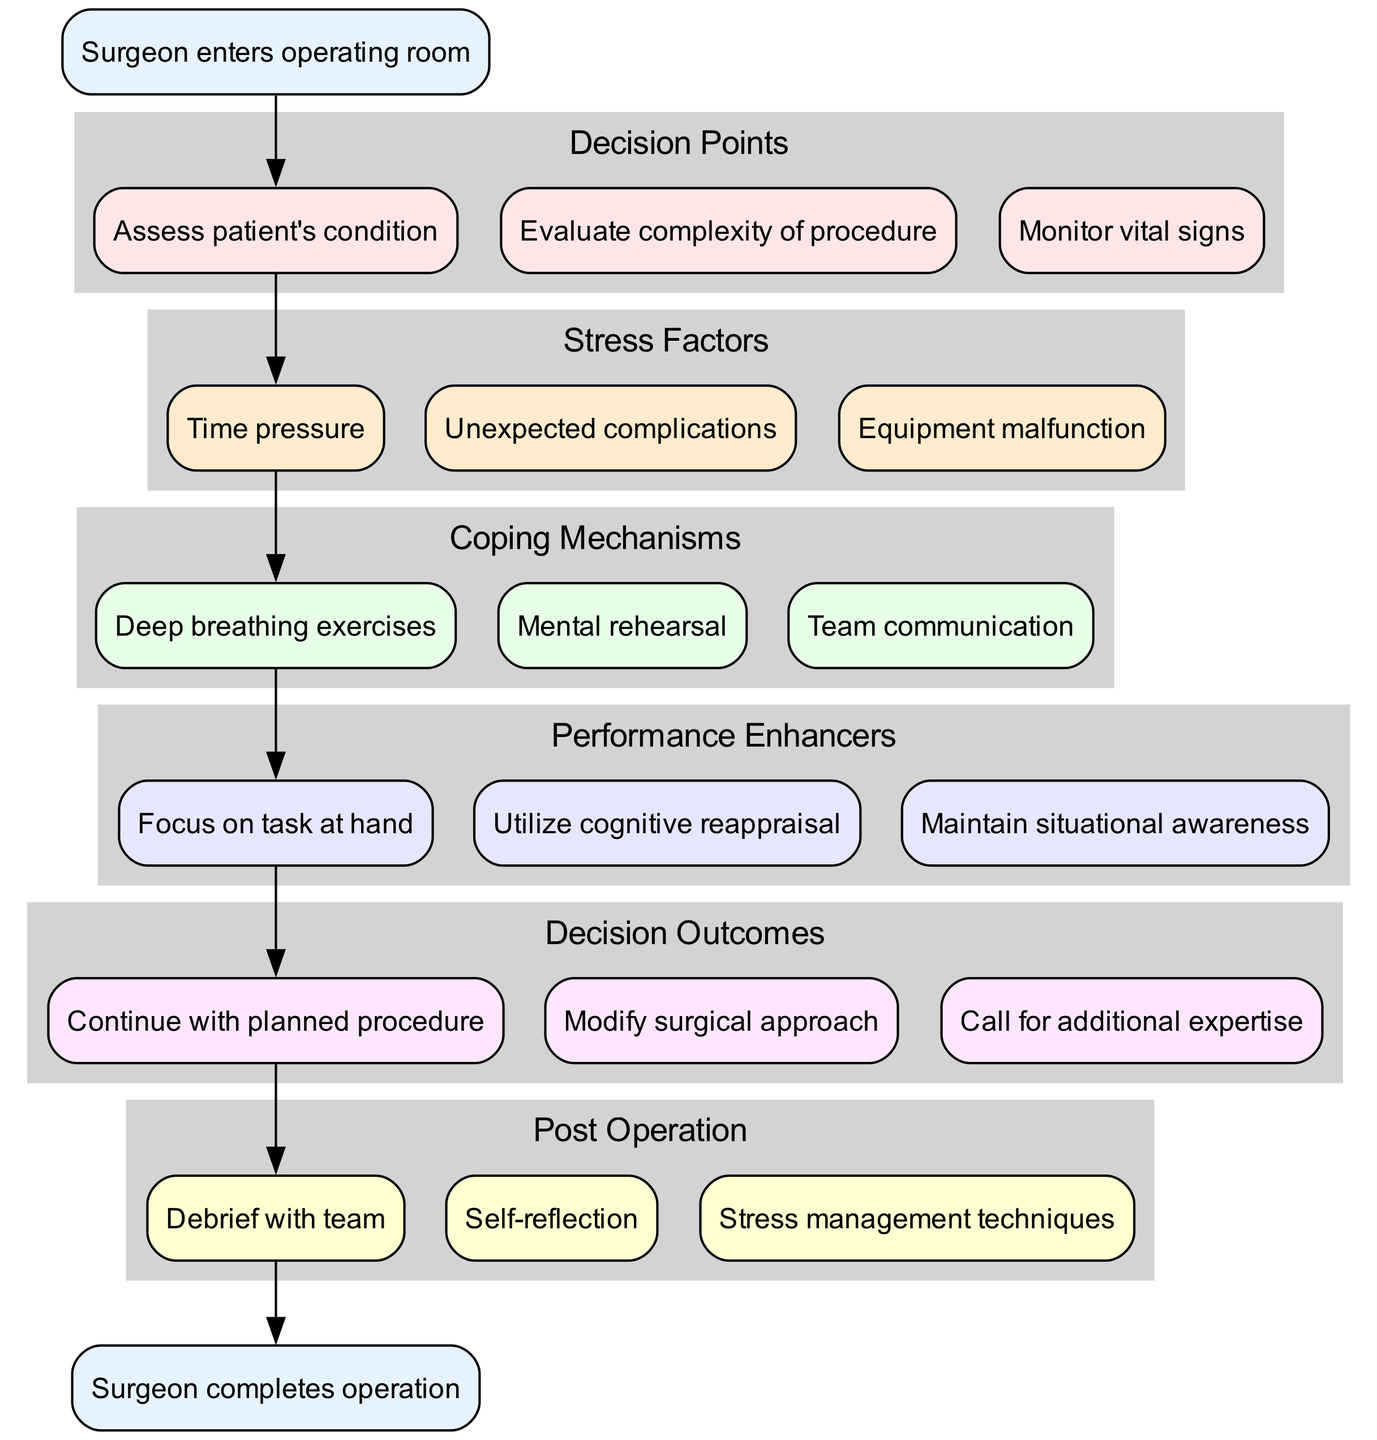What is the first action a surgeon takes upon entering the operating room? The first action as indicated in the diagram is "Surgeon enters operating room." This node is the starting point of the flow chart.
Answer: Surgeon enters operating room What are the stress factors outlined in the diagram? The stress factors are listed as nodes in the "Stress Factors" cluster. They include "Time pressure," "Unexpected complications," and "Equipment malfunction."
Answer: Time pressure, Unexpected complications, Equipment malfunction How many coping mechanisms are mentioned in the flow chart? The diagram includes three nodes under the "Coping Mechanisms" cluster, specifying the coping strategies available to surgeons.
Answer: 3 Which performance enhancer follows the mental rehearsal coping mechanism? Following the "Mental rehearsal" node in the coping mechanisms, the next node in the flow is "Focus on task at hand." This arrangement shows the sequence of applying coping strategies leading to enhanced performance.
Answer: Focus on task at hand If a surgeon faces unexpected complications, what is the expected outcome based on the diagram? Given the stress factor of "Unexpected complications," the flow would likely lead to a decision point. Consequently, this would affect the outcome, potentially to "Modify surgical approach," as this modification reacts to the complexity of the situation.
Answer: Modify surgical approach What does the end node signify after the surgeon completes all steps? The end node articulates the conclusion of the process, clearly defined as "Surgeon completes operation," indicating that after following all necessary steps and responses, the operation is finished successfully.
Answer: Surgeon completes operation What are the specific actions a surgeon takes post-operation according to the diagram? The post-operation cluster outlines actions such as "Debrief with team," "Self-reflection," and "Stress management techniques." This collection emphasizes the importance of reviewing and managing stress after the operation.
Answer: Debrief with team, Self-reflection, Stress management techniques How does team communication relate to coping mechanisms for surgeons? "Team communication" is directly listed as one of the coping mechanisms in the diagram, indicating that effective communication within the team is a strategic response to stress encountered during surgery.
Answer: Team communication What is the relationship between the "Assess patient’s condition" and "Monitor vital signs"? Both "Assess patient's condition" and "Monitor vital signs" are decision points that denote critical tasks a surgeon must engage in when entering the operating room, thus these nodes represent parallel actions that help inform subsequent decision-making.
Answer: Parallel actions 